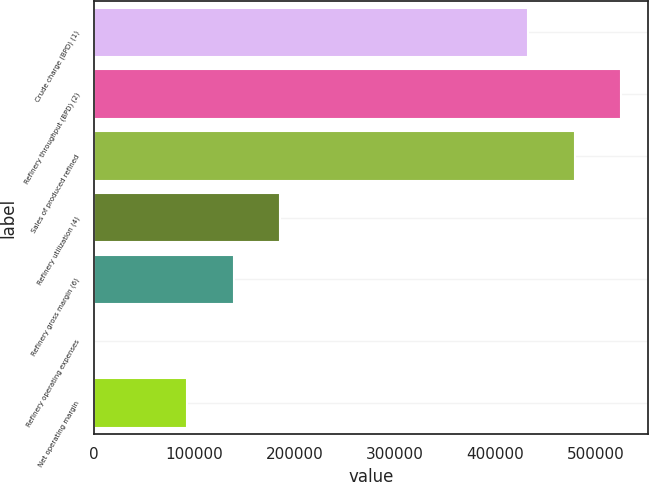<chart> <loc_0><loc_0><loc_500><loc_500><bar_chart><fcel>Crude charge (BPD) (1)<fcel>Refinery throughput (BPD) (2)<fcel>Sales of produced refined<fcel>Refinery utilization (4)<fcel>Refinery gross margin (6)<fcel>Refinery operating expenses<fcel>Net operating margin<nl><fcel>432560<fcel>525275<fcel>478917<fcel>185435<fcel>139078<fcel>5.56<fcel>92720.4<nl></chart> 